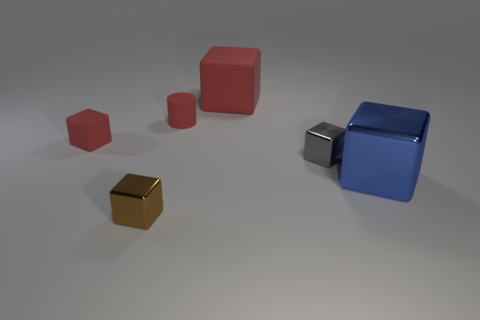There is another block that is the same color as the tiny matte cube; what is its size?
Provide a short and direct response. Large. What is the material of the small thing that is the same color as the small cylinder?
Ensure brevity in your answer.  Rubber. There is a shiny thing that is both behind the brown metal thing and left of the large metallic cube; what is its shape?
Your response must be concise. Cube. What is the color of the cylinder that is the same material as the big red object?
Your response must be concise. Red. Are there the same number of big things on the right side of the large red rubber cube and brown shiny blocks?
Keep it short and to the point. Yes. What shape is the red matte object that is the same size as the blue cube?
Offer a terse response. Cube. How many other things are there of the same shape as the large red object?
Keep it short and to the point. 4. Do the blue object and the shiny thing that is in front of the large blue metal object have the same size?
Your answer should be very brief. No. What number of things are either tiny things to the left of the tiny gray metallic object or big objects?
Give a very brief answer. 5. What shape is the tiny red object left of the small brown metallic block?
Provide a short and direct response. Cube. 